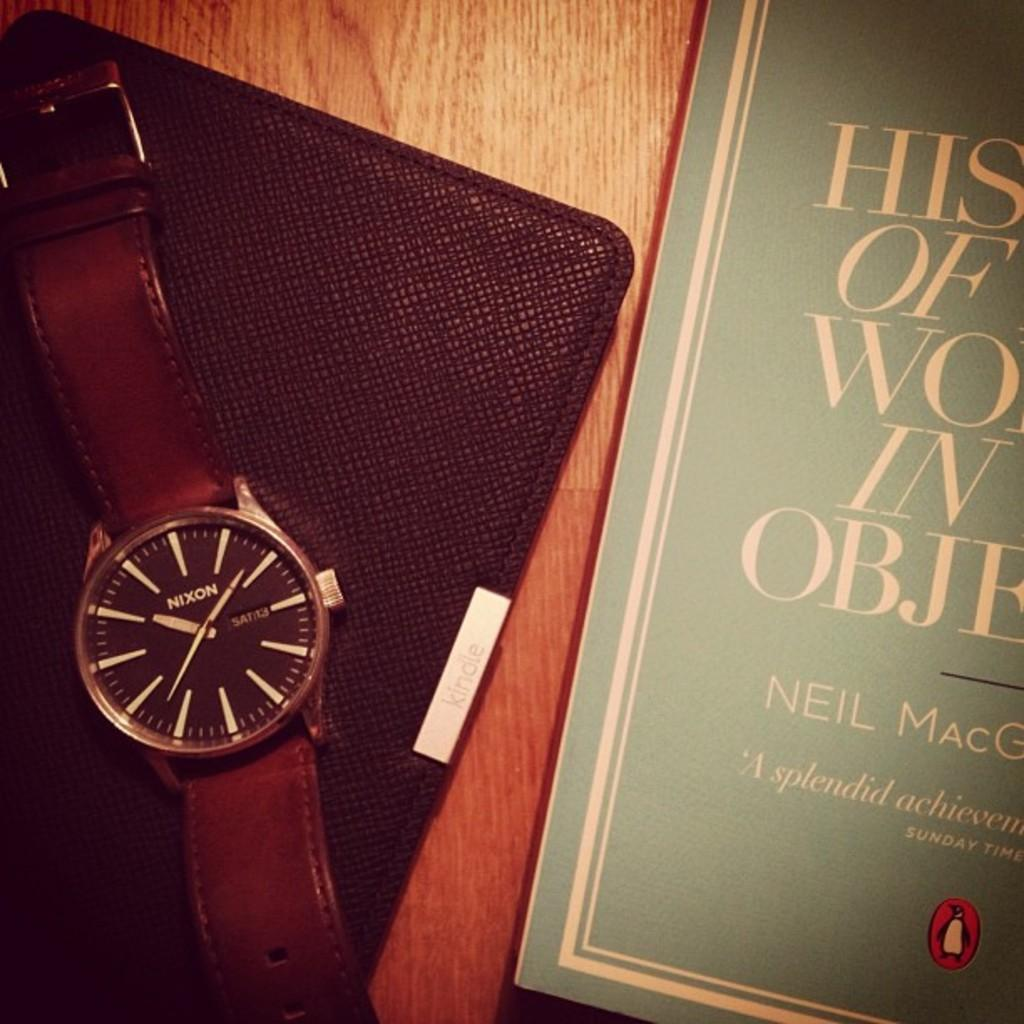<image>
Summarize the visual content of the image. The second's hand on the brown watch is at 37 and the time is 10:09. 